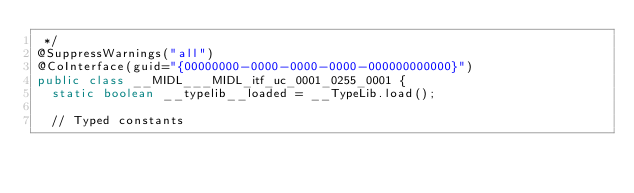Convert code to text. <code><loc_0><loc_0><loc_500><loc_500><_Java_> */
@SuppressWarnings("all")
@CoInterface(guid="{00000000-0000-0000-0000-000000000000}")
public class __MIDL___MIDL_itf_uc_0001_0255_0001 {
  static boolean __typelib__loaded = __TypeLib.load();

  // Typed constants</code> 